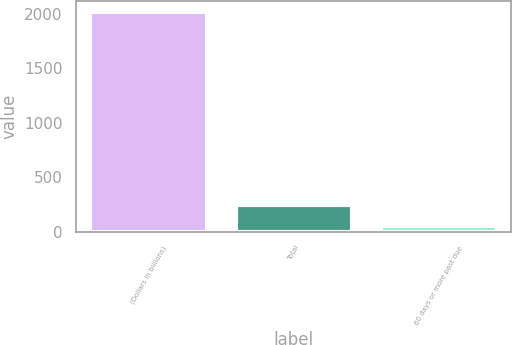<chart> <loc_0><loc_0><loc_500><loc_500><bar_chart><fcel>(Dollars in billions)<fcel>Total<fcel>60 days or more past due<nl><fcel>2013<fcel>245.4<fcel>49<nl></chart> 